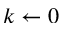<formula> <loc_0><loc_0><loc_500><loc_500>k \leftarrow 0</formula> 